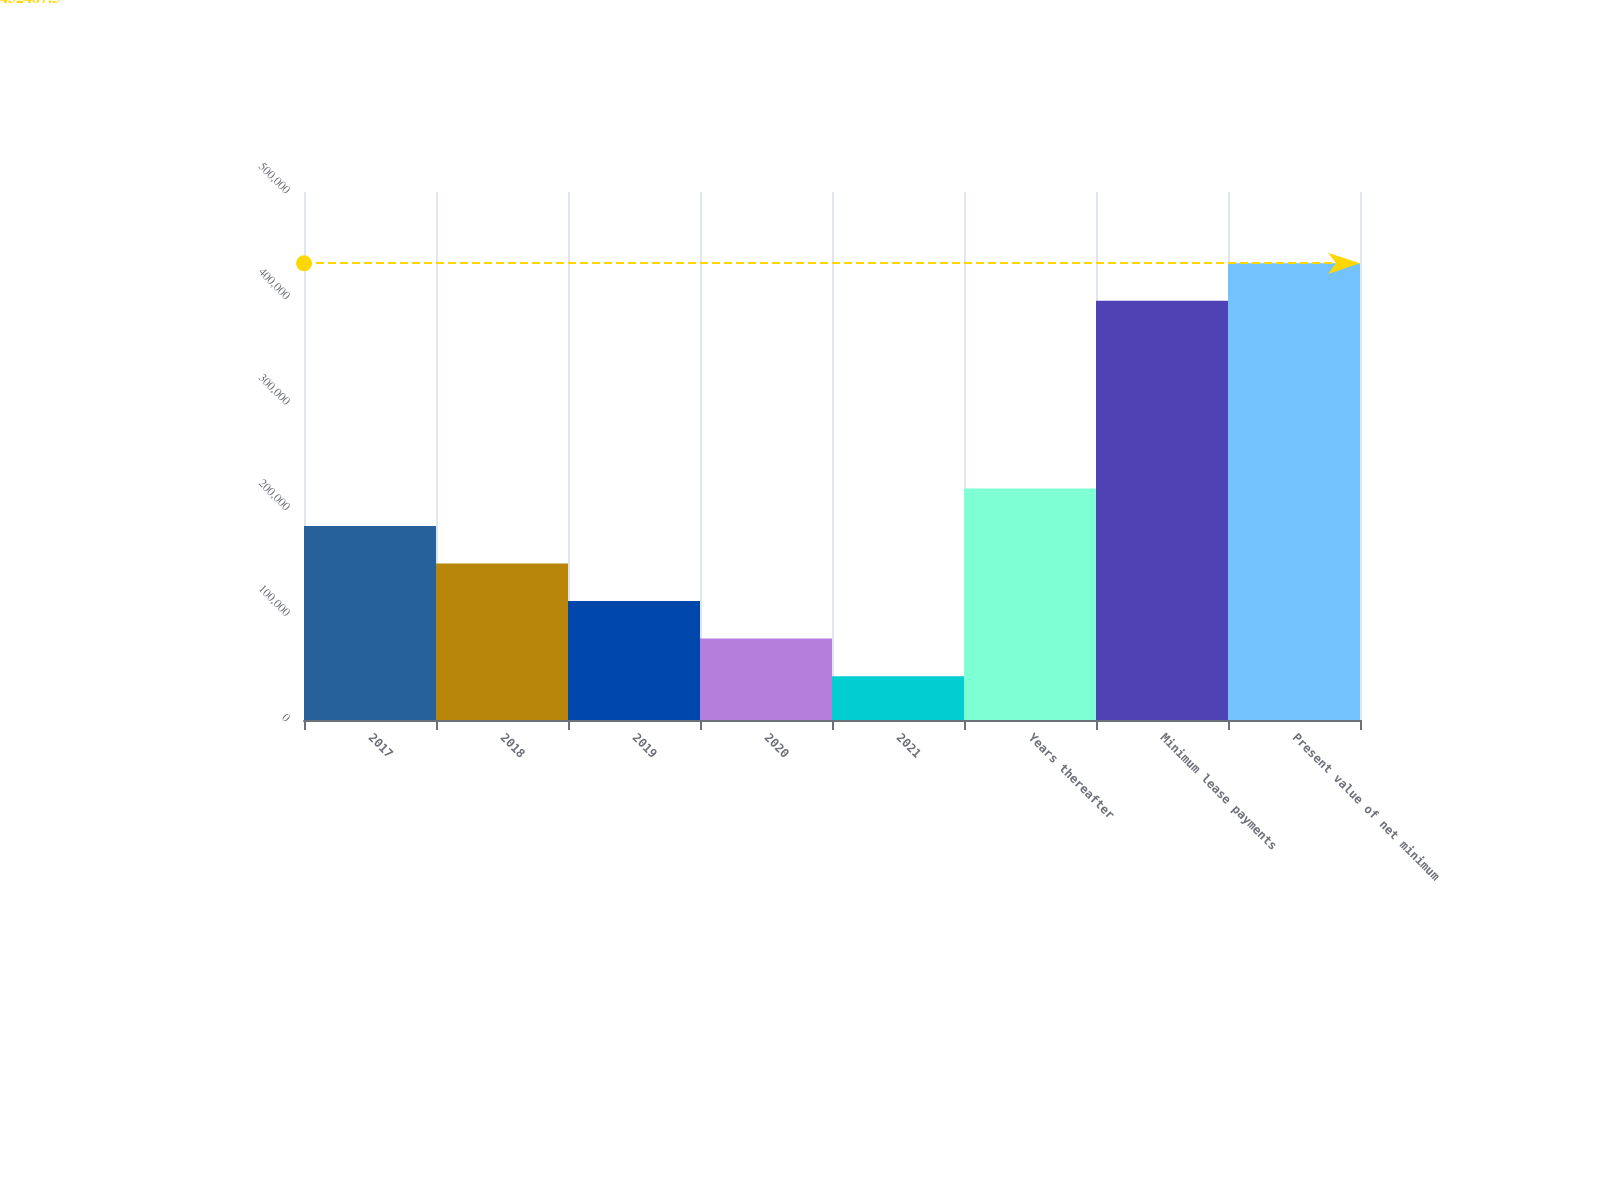<chart> <loc_0><loc_0><loc_500><loc_500><bar_chart><fcel>2017<fcel>2018<fcel>2019<fcel>2020<fcel>2021<fcel>Years thereafter<fcel>Minimum lease payments<fcel>Present value of net minimum<nl><fcel>183697<fcel>148156<fcel>112614<fcel>77072.5<fcel>41531<fcel>219238<fcel>396946<fcel>432488<nl></chart> 